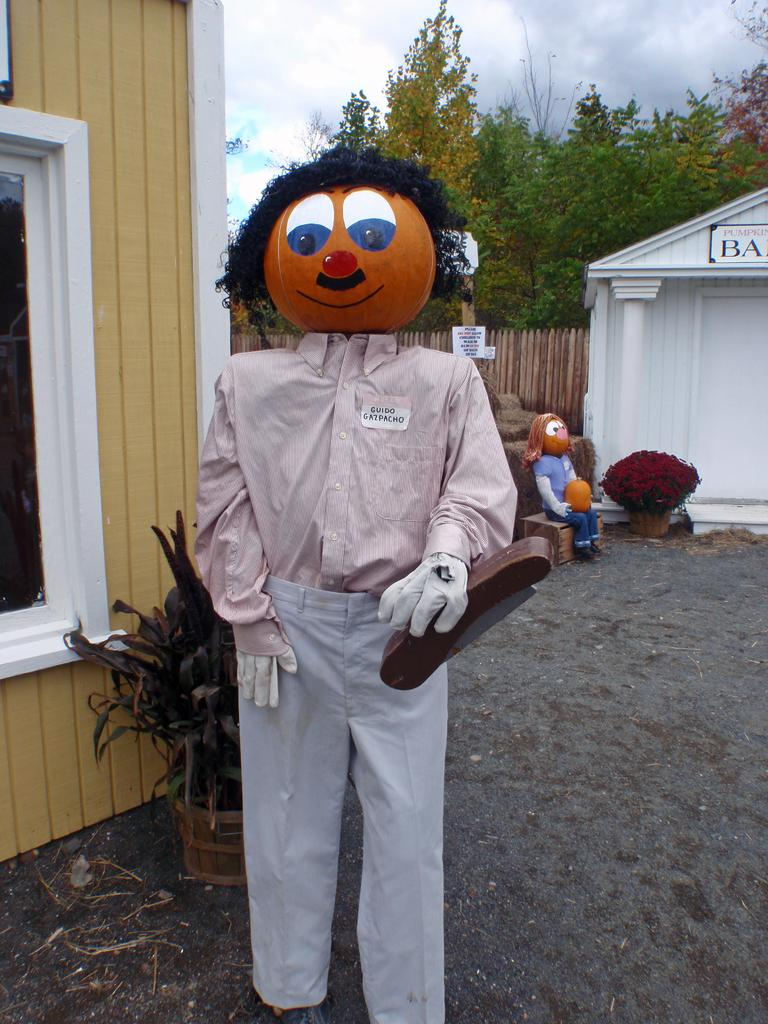What is located in the foreground of the image? There is a toy person standing in the foreground of the image. What can be seen in the background of the image? There are plants, a building, trees, and another toy in the background of the image. What is visible in the sky in the image? The sky is visible in the background of the image, and there is a cloud in the sky. What type of art is being used to support the toy person in the image? There is no art or support visible in the image; the toy person is standing on its own. What thing is being used to hold the toy person in the image? There is no thing or support holding the toy person in the image; it is standing on its own. 